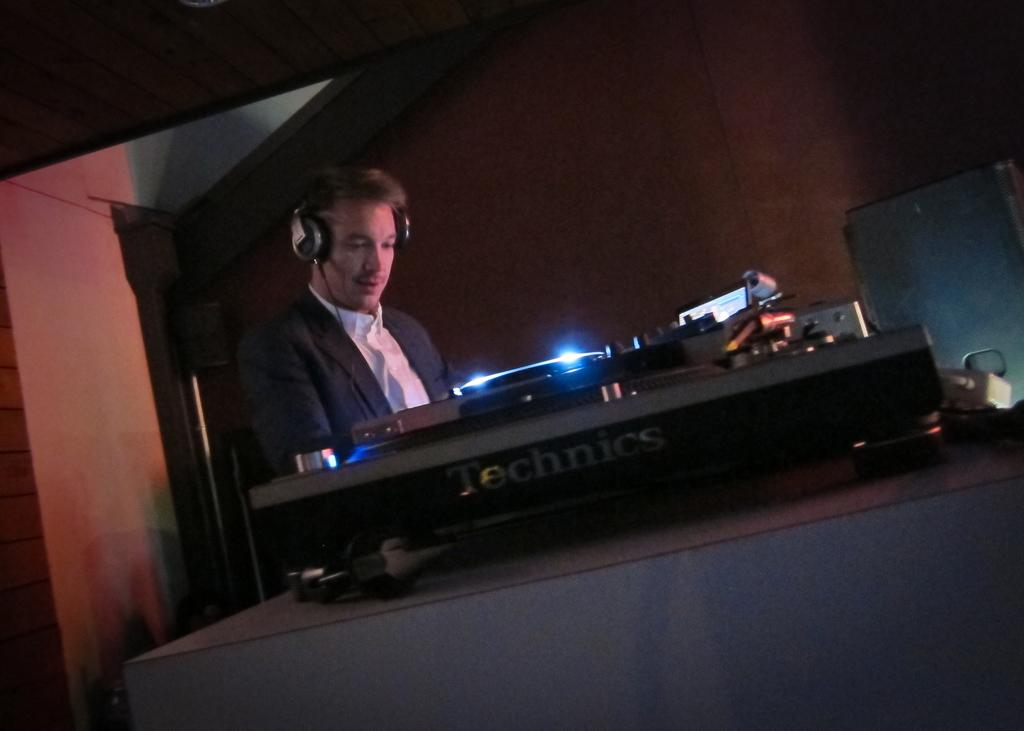<image>
Present a compact description of the photo's key features. A man with headphones is using Technics equipment. 